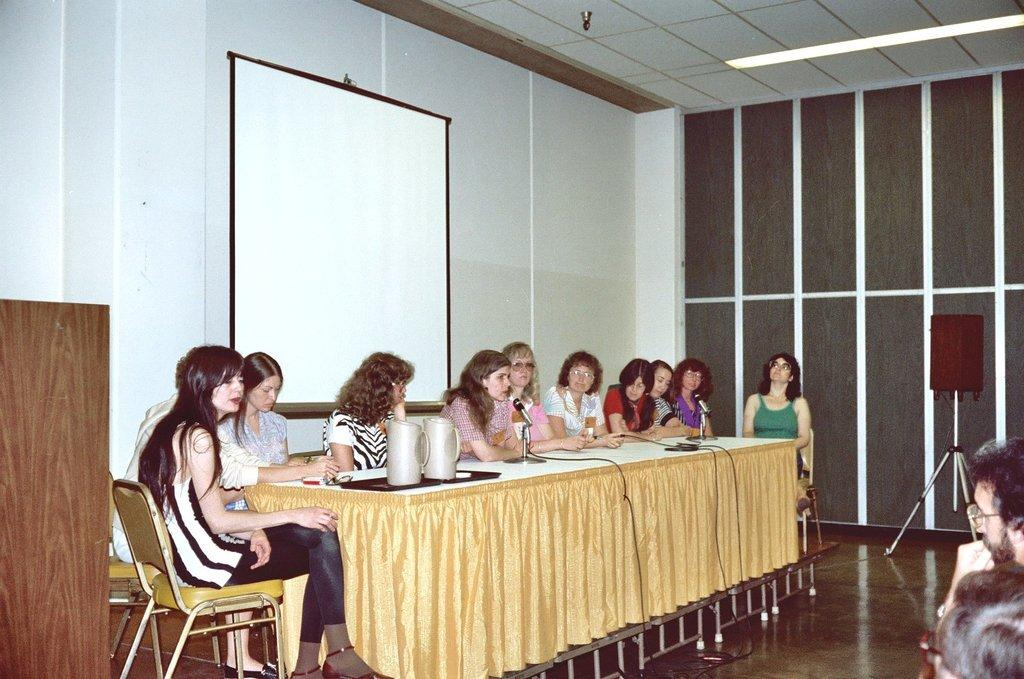What are the women in the image doing? The women are sitting on chairs in the image. What objects can be seen on the table in the image? There are jugs and microphones on the table in the image. What is the purpose of the projector screen in the image? The projector screen is likely used for presentations or displaying visuals. What device is present in the image for amplifying sound? There is a speaker in the image. What type of skin condition can be seen on the women in the image? There is no indication of any skin condition on the women in the image. What thrilling activity are the women participating in during the meeting? The image does not depict any thrilling activities; the women are simply sitting on chairs. 